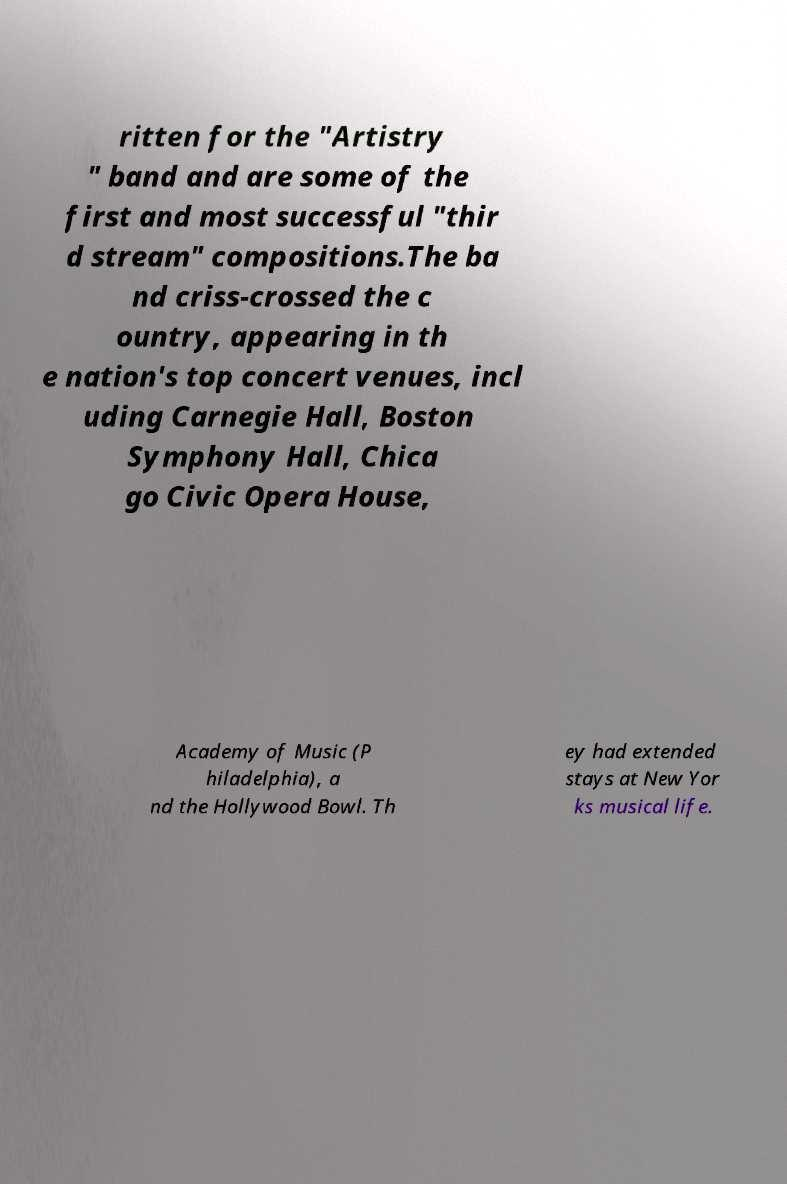I need the written content from this picture converted into text. Can you do that? ritten for the "Artistry " band and are some of the first and most successful "thir d stream" compositions.The ba nd criss-crossed the c ountry, appearing in th e nation's top concert venues, incl uding Carnegie Hall, Boston Symphony Hall, Chica go Civic Opera House, Academy of Music (P hiladelphia), a nd the Hollywood Bowl. Th ey had extended stays at New Yor ks musical life. 